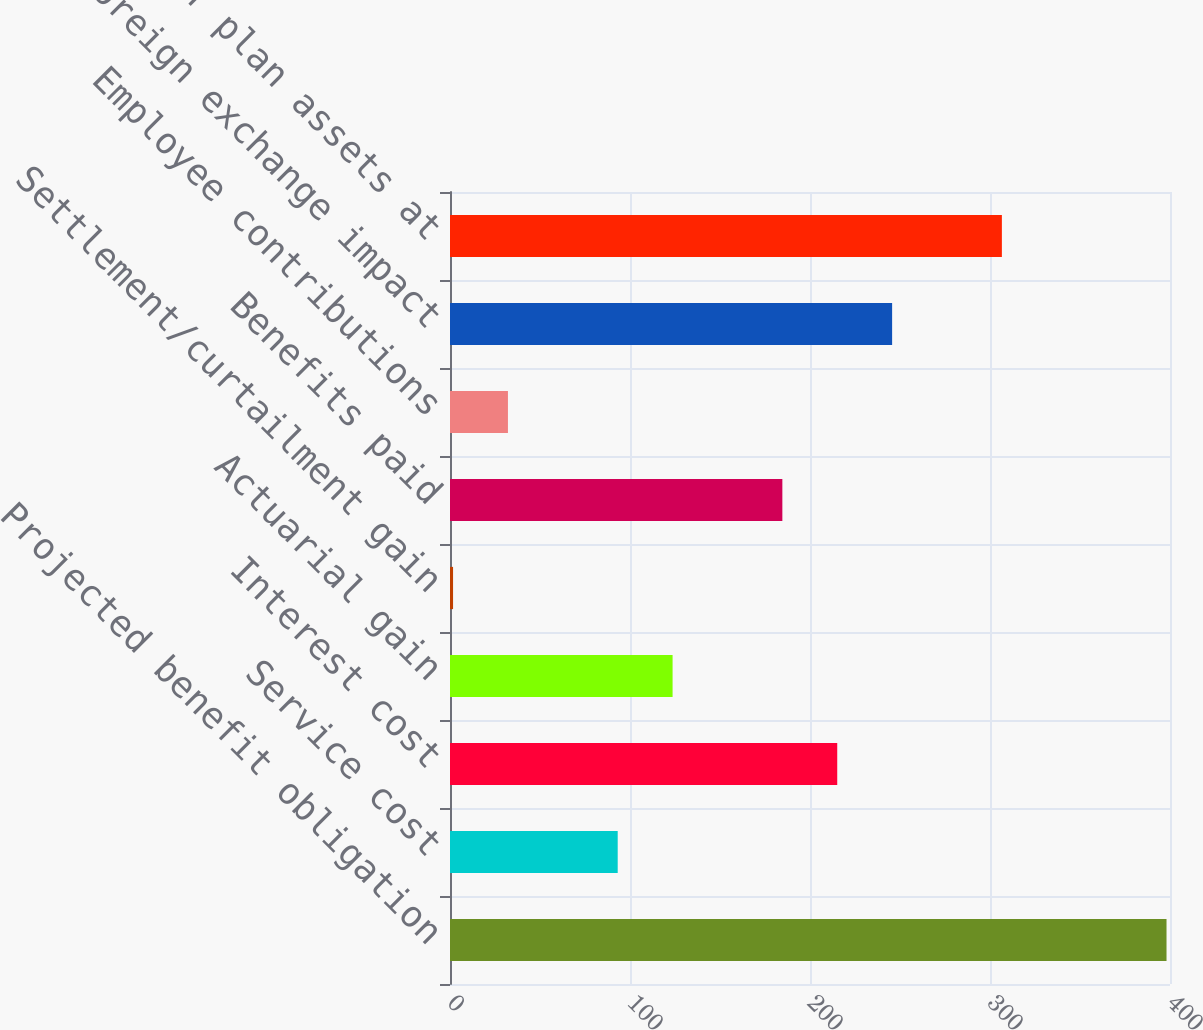Convert chart to OTSL. <chart><loc_0><loc_0><loc_500><loc_500><bar_chart><fcel>Projected benefit obligation<fcel>Service cost<fcel>Interest cost<fcel>Actuarial gain<fcel>Settlement/curtailment gain<fcel>Benefits paid<fcel>Employee contributions<fcel>Foreign exchange impact<fcel>Fair value of plan assets at<nl><fcel>398.07<fcel>93.17<fcel>215.13<fcel>123.66<fcel>1.7<fcel>184.64<fcel>32.19<fcel>245.62<fcel>306.6<nl></chart> 